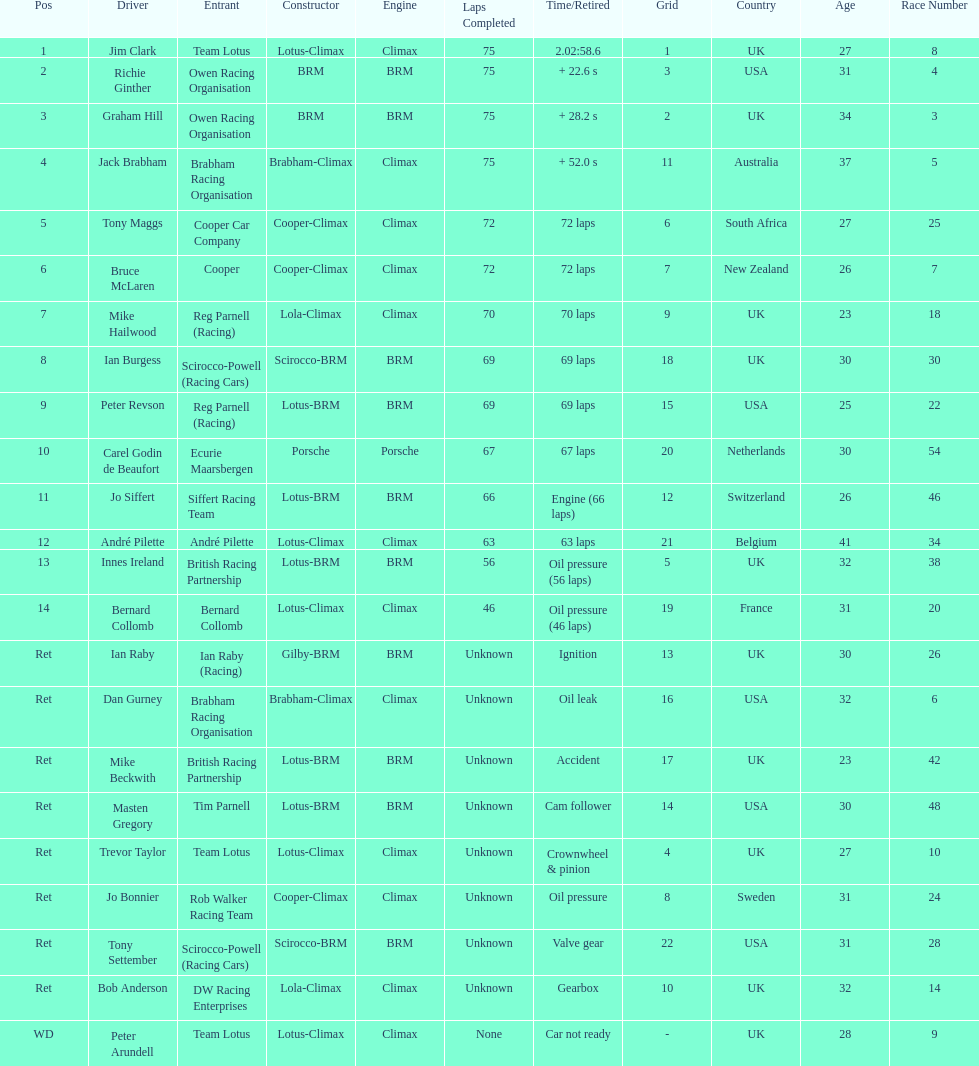How many racers had cooper-climax as their constructor? 3. 